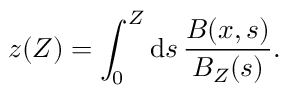Convert formula to latex. <formula><loc_0><loc_0><loc_500><loc_500>z ( Z ) = \int _ { 0 } ^ { Z } d s \, \frac { B ( x , s ) } { B _ { Z } ( s ) } .</formula> 